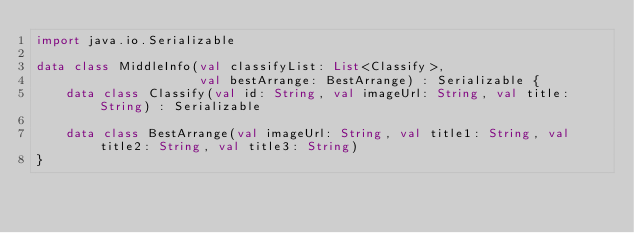<code> <loc_0><loc_0><loc_500><loc_500><_Kotlin_>import java.io.Serializable

data class MiddleInfo(val classifyList: List<Classify>,
                      val bestArrange: BestArrange) : Serializable {
    data class Classify(val id: String, val imageUrl: String, val title: String) : Serializable

    data class BestArrange(val imageUrl: String, val title1: String, val title2: String, val title3: String)
}

</code> 